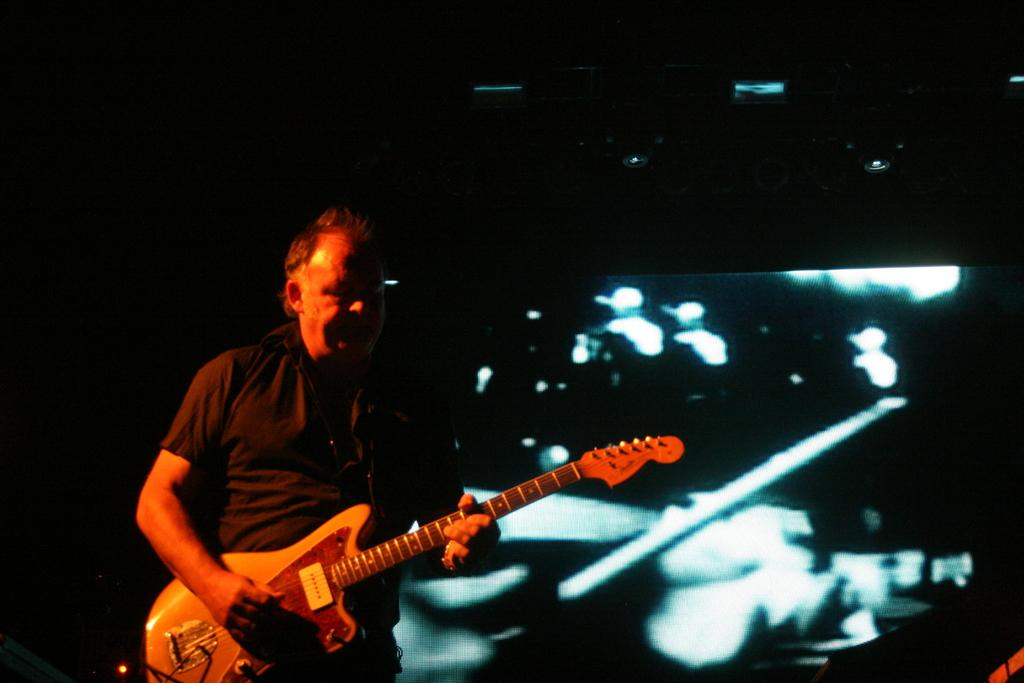What is the man in the image doing? The man is playing a guitar in the image. What can be seen in the background of the image? The background of the image is dark. What might be on the right side of the image? There appears to be a screen on the right side of the image. What type of frog can be seen sitting on the shelf in the image? There is no frog or shelf present in the image. 